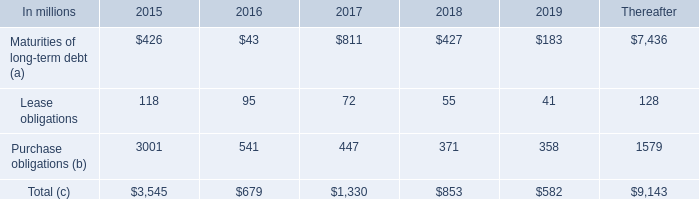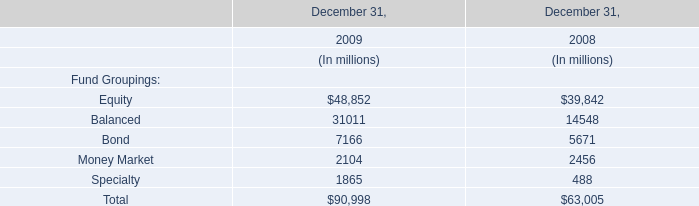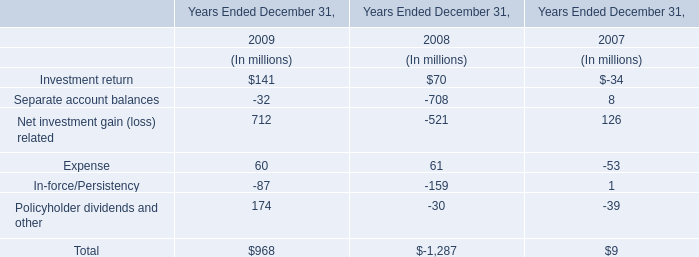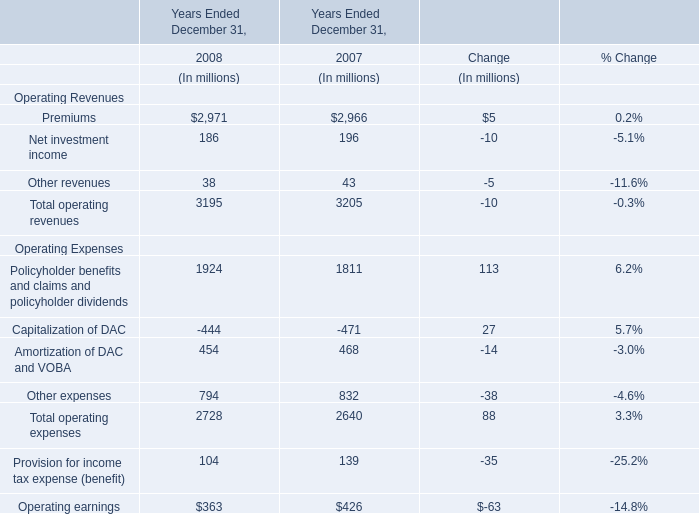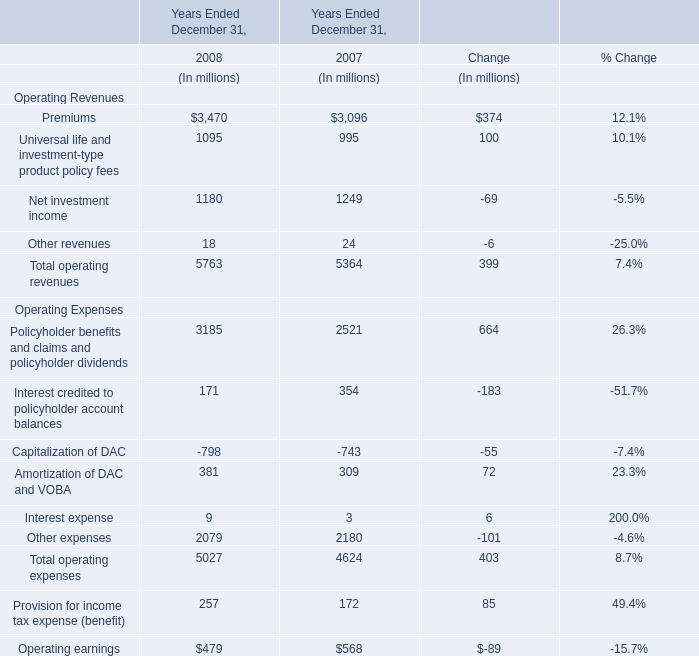If Total operating revenues develops with the same growth rate in 2008, what will it reach in 2009? (in million) 
Computations: (5763 * (1 + ((5763 - 5364) / 5364)))
Answer: 6191.67953. 